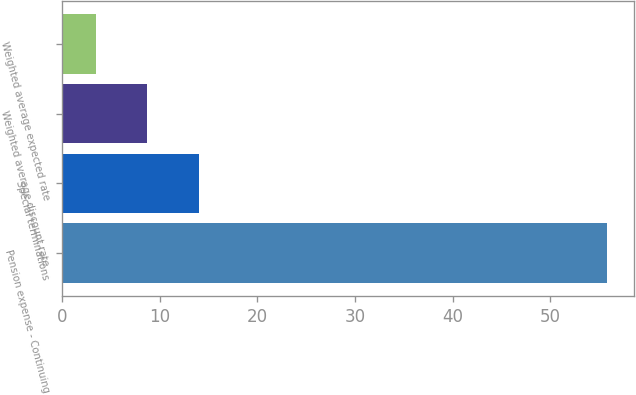<chart> <loc_0><loc_0><loc_500><loc_500><bar_chart><fcel>Pension expense - Continuing<fcel>Special terminations<fcel>Weighted average discount rate<fcel>Weighted average expected rate<nl><fcel>55.8<fcel>13.96<fcel>8.73<fcel>3.5<nl></chart> 